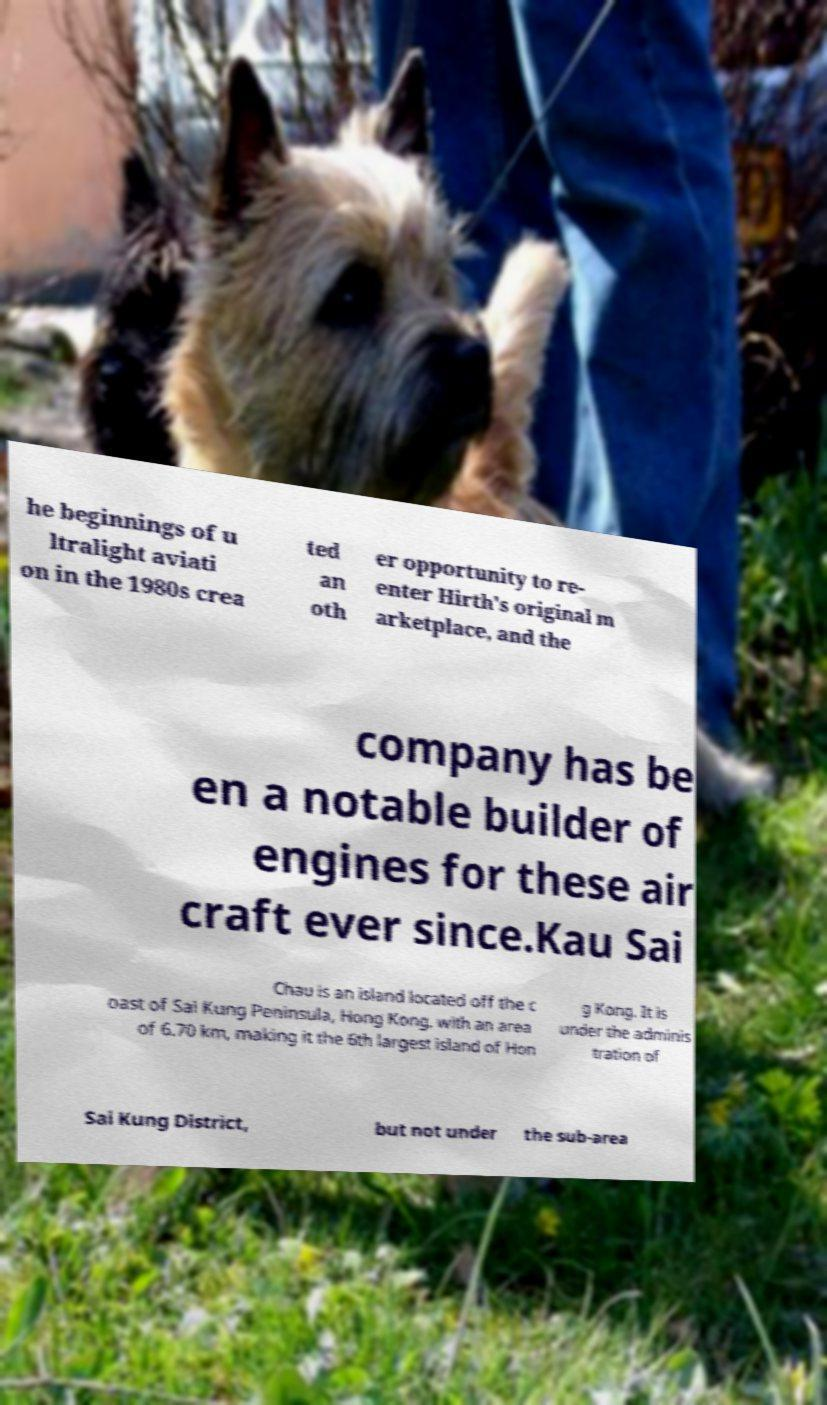Can you accurately transcribe the text from the provided image for me? he beginnings of u ltralight aviati on in the 1980s crea ted an oth er opportunity to re- enter Hirth's original m arketplace, and the company has be en a notable builder of engines for these air craft ever since.Kau Sai Chau is an island located off the c oast of Sai Kung Peninsula, Hong Kong, with an area of 6.70 km, making it the 6th largest island of Hon g Kong. It is under the adminis tration of Sai Kung District, but not under the sub-area 